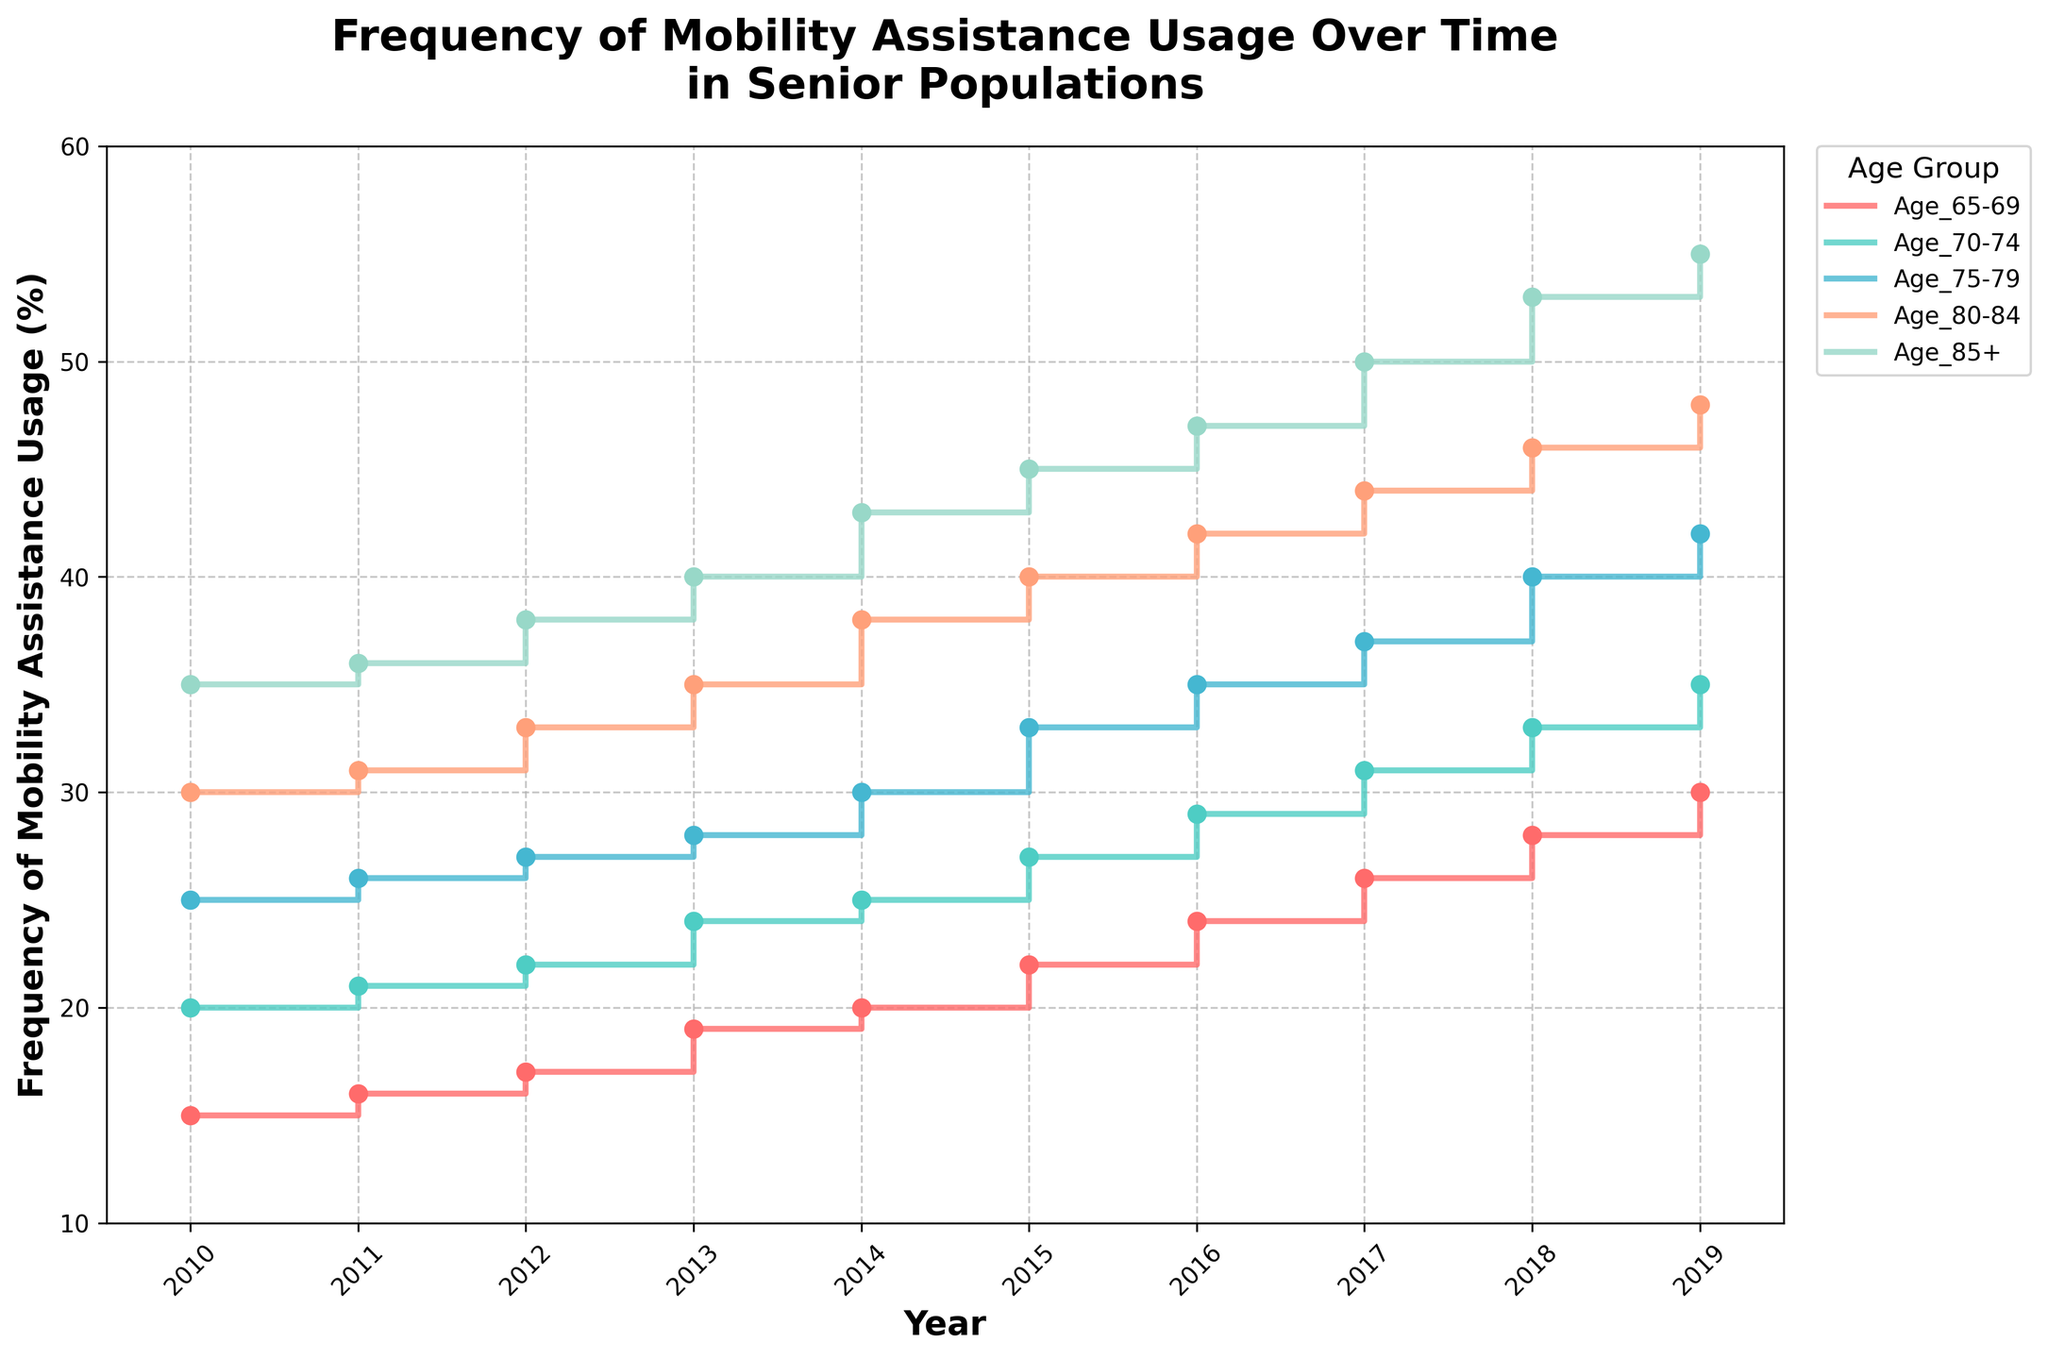What is the title of the figure? The title is typically located at the top of the figure and provides an overview of the main subject. In this case, the title is given in the code provided: "Frequency of Mobility Assistance Usage Over Time in Senior Populations.”
Answer: Frequency of Mobility Assistance Usage Over Time in Senior Populations What is the range of years displayed on the x-axis? The x-axis contains the years, which represent the timeline of the data. From 2009.5 to 2019.5, the ticks typically start from 2010 and end at 2019.
Answer: 2010 to 2019 Which age group had the highest frequency of mobility assistance usage in 2019? By looking at the data points for 2019 and checking which line reaches the highest value on the y-axis, the age group 85+ had the highest frequency.
Answer: Age 85+ Which age group showed the most considerable increase in mobility assistance usage from 2010 to 2019? To determine this, subtract the 2010 value from the 2019 value for each age group and compare these differences. The age group 85+ had the highest increase: 55 - 35 = 20%.
Answer: Age 85+ In what year did the Age 80-84 group surpass a 40% frequency of mobility assistance usage? To find this, locate the data points for the Age 80-84 line and identify when it first exceeds 40% on the y-axis. Based on the data, this occurred in 2015.
Answer: 2015 What is the approximate overall trend in mobility assistance usage frequency across all age groups from 2010 to 2019? By observing the direction of the lines over the years for all age groups, it's clear that the overall trend is an increasing one.
Answer: Increasing How many distinct age groups are represented in the figure? The legend or different colored lines indicate the distinct age groups represented. In this case, there are five age groups: Age 65-69, Age 70-74, Age 75-79, Age 80-84, and Age 85+.
Answer: 5 Which age group had the smallest increase in mobility assistance usage from 2010 to 2014? By calculating the difference between the 2014 and 2010 values for each group and comparing them, the Age 65-69 group showed the smallest increase: 20 - 15 = 5%.
Answer: Age 65-69 